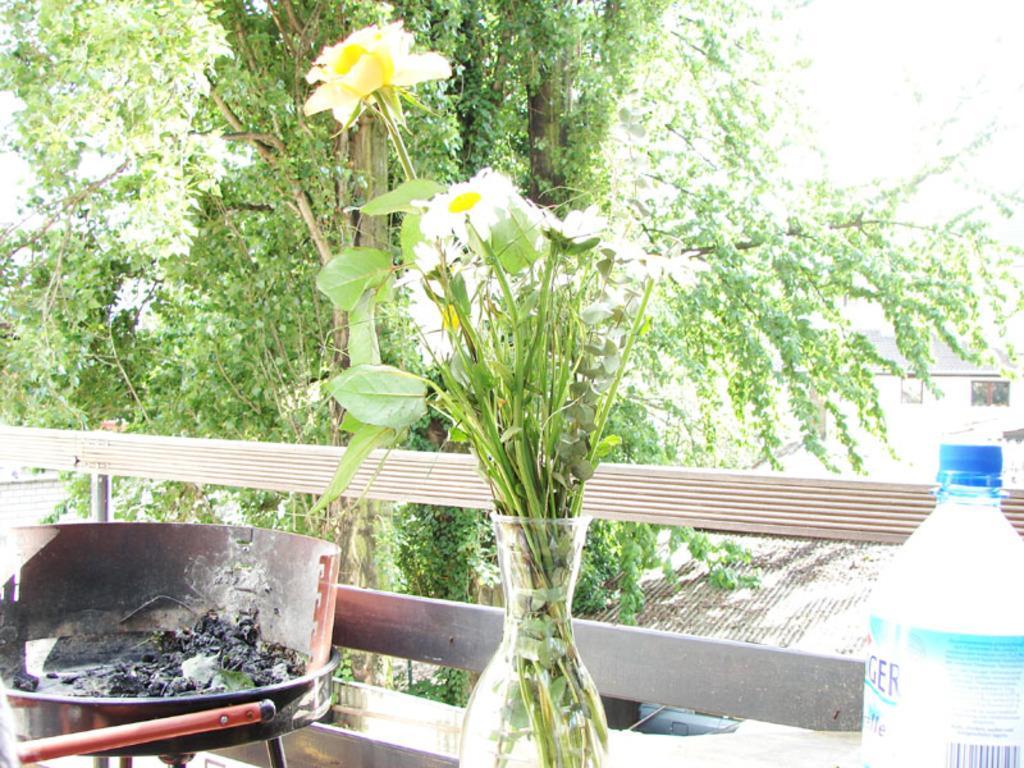In one or two sentences, can you explain what this image depicts? There is vase with with white flowers and leaves in it and beside that there is a bottle and other side there is a coal burning in tray. Behind that there are so many trees. 